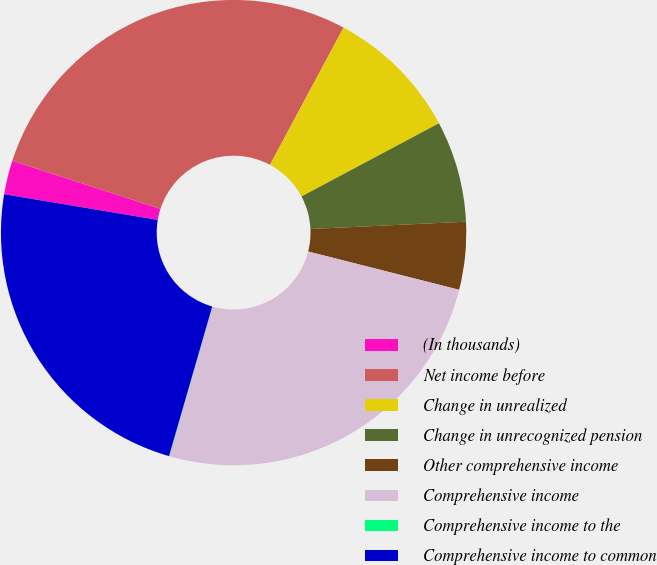Convert chart to OTSL. <chart><loc_0><loc_0><loc_500><loc_500><pie_chart><fcel>(In thousands)<fcel>Net income before<fcel>Change in unrealized<fcel>Change in unrecognized pension<fcel>Other comprehensive income<fcel>Comprehensive income<fcel>Comprehensive income to the<fcel>Comprehensive income to common<nl><fcel>2.36%<fcel>27.84%<fcel>9.38%<fcel>7.04%<fcel>4.7%<fcel>25.5%<fcel>0.03%<fcel>23.16%<nl></chart> 